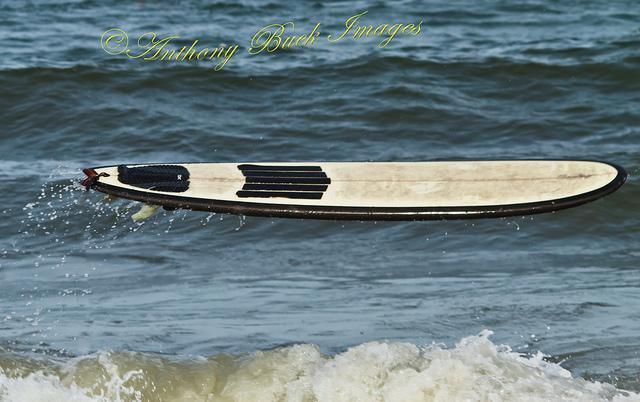How many surfboards are there?
Give a very brief answer. 1. 